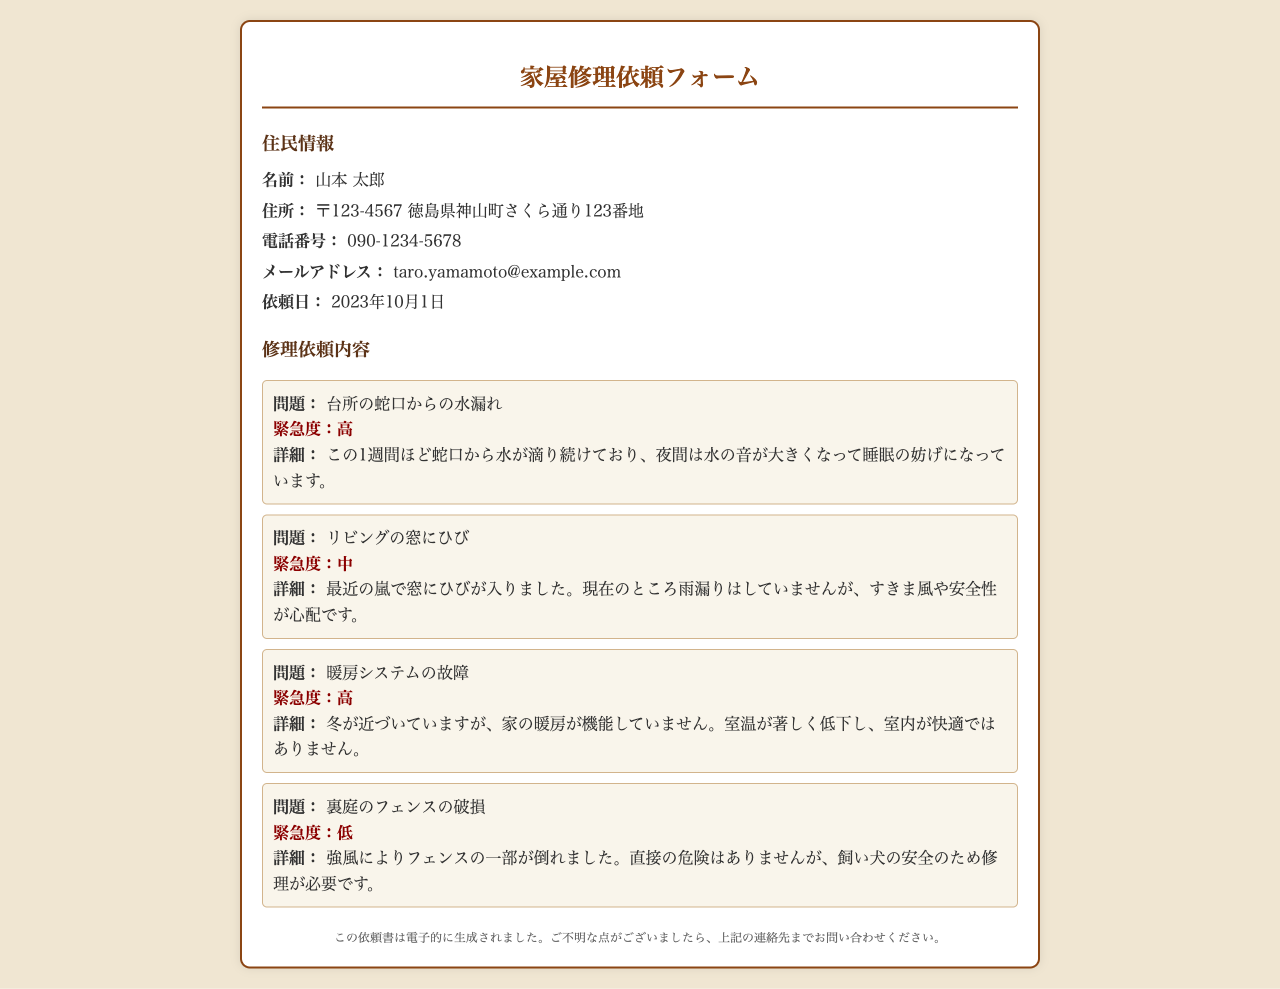名前は何ですか？ 住民情報のセクションに「名前」として記載されています。
Answer: 山本 太郎 住所はどこですか？ 住民情報のセクションに「住所」として記載されています。
Answer: 〒123-4567 徳島県神山町さくら通り123番地 依頼日はいつですか？ 住民情報セクションに「依頼日」として記載されています。
Answer: 2023年10月1日 蛇口からの水漏れに関する緊急度は？ 修理依頼内容セクションの蛇口問題の緊急度を示す部分に記載されています。
Answer: 高 裏庭のフェンスの問題に対する緊急度は？ 修理依頼内容セクションで裏庭のフェンスの問題に関する緊急度を示す部分に記載されています。
Answer: 低 リビングの窓にひびが入った理由は何ですか？ 修理依頼内容のリビングの窓の問題に関する詳細に記載されています。
Answer: 最近の嵐 暖房システムが機能しない理由は？ 修理依頼内容の暖房システムに関する詳細情報に基づいています。
Answer: 故障 電話番号は何ですか？ 住民情報のセクションに「電話番号」として記載されています。
Answer: 090-1234-5678 この依頼書はどのように生成されましたか？ フッターの部分にこの依頼書の生成方法について記載されています。
Answer: 電子的に生成されました 